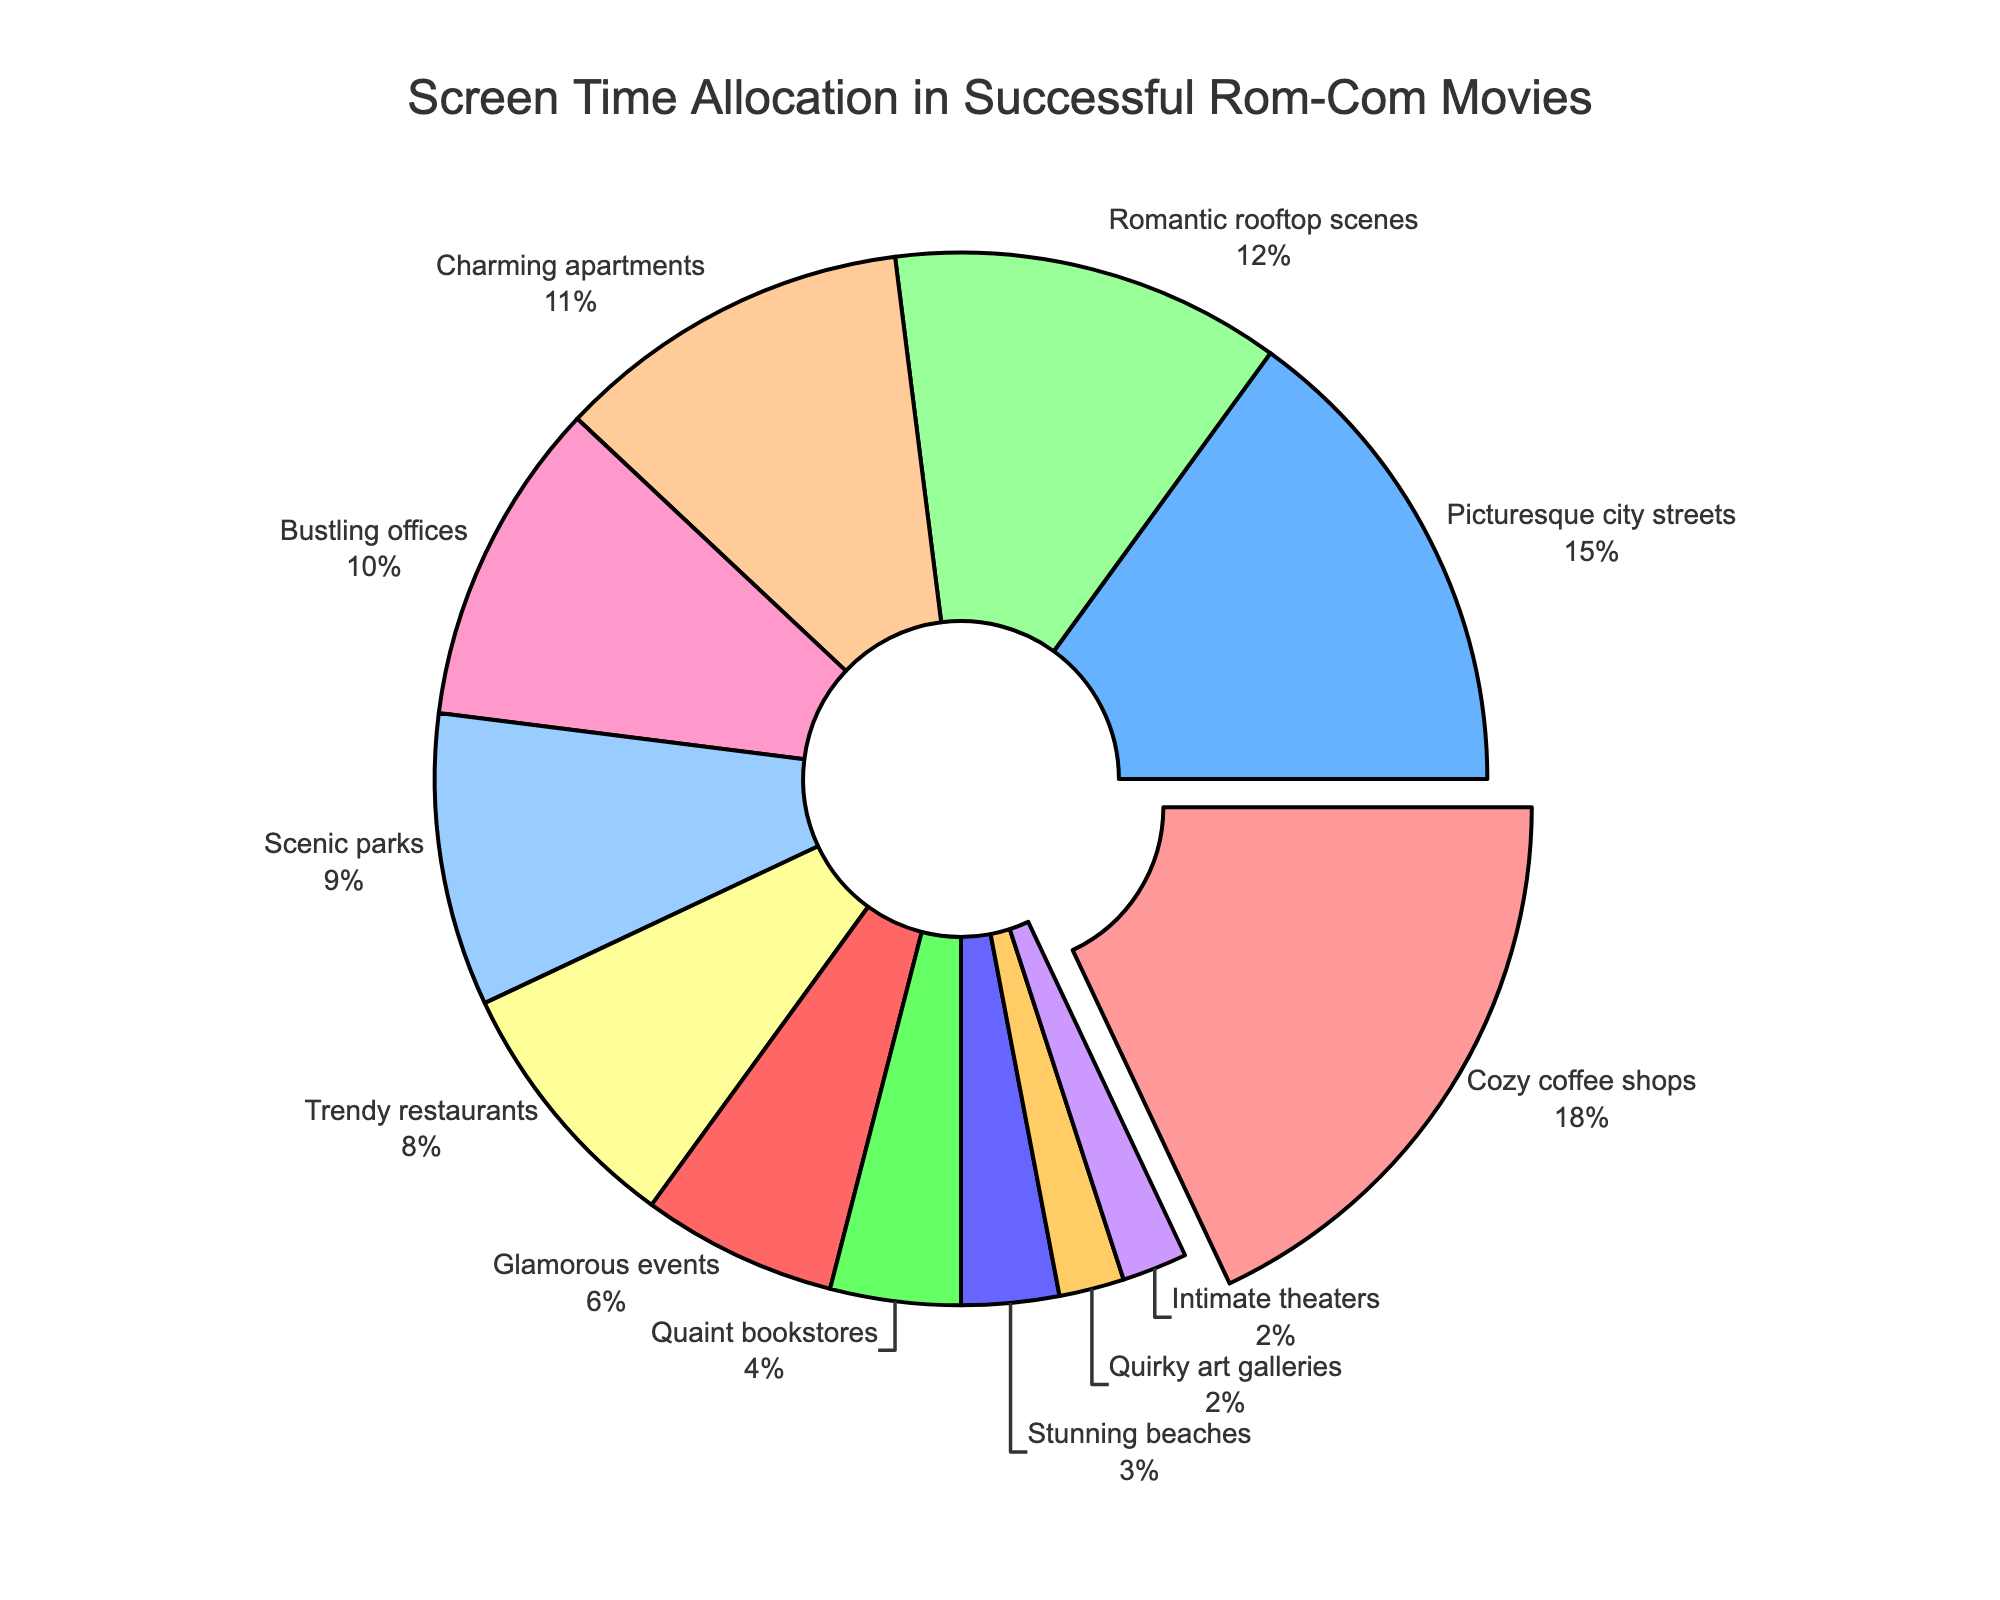What's the location with the highest screen time allocation? The location with the highest screen time allocation is visually highlighted by being pulled out from the rest of the pie chart and its percentage is clearly marked. It is the "Cozy coffee shops" with 18%.
Answer: Cozy coffee shops Which two locations combined have just over 30% of the screen time allocation? We need to add the percentages of different locations to find a combination that just exceeds 30%. "Picturesque city streets" (15%) and "Romantic rooftop scenes" (12%) together give us 27%, but adding "Charming apartments" (11%) results in a sum of 38%, exceeding 30%. Instead, "Cozy coffee shops" (18%) combined with "Picturesque city streets" (15%) gives us 33%, which is just over 30%.
Answer: Cozy coffee shops and Picturesque city streets How do the screen time allocations of "Glamorous events" and "Bustling offices" compare? "Bustling offices" have 10% of the screen time allocation, and "Glamorous events" have 6%. To compare, "Bustling offices" have 4% more screen time allocation than "Glamorous events".
Answer: Bustling offices have more Which location has the smallest screen time allocation? The smallest segment of the pie chart represents this location. It is "Quirky art galleries" and "Intimate theaters", each contributing 2% of the screen time allocation.
Answer: Quirky art galleries and Intimate theaters What is the combined screen time allocation for "Trendy restaurants," "Charming apartments," and "Scenic parks"? Adding the percentages of these locations: "Trendy restaurants" (8%), "Charming apartments" (11%), and "Scenic parks" (9%) gives a total of 8 + 11 + 9 = 28%.
Answer: 28% Is the screen time allocation for "Stunning beaches" greater than that of "Intimate theaters"? "Stunning beaches" have 3% of the screen time allocation, and "Intimate theaters" have 2%. Therefore, the allocation for "Stunning beaches" is greater.
Answer: Yes What percentage of screen time do the top three locations account for? The top three locations are "Cozy coffee shops" (18%), "Picturesque city streets" (15%), and "Romantic rooftop scenes" (12%). Adding these gives 18 + 15 + 12 = 45%.
Answer: 45% Compare the screen time allocation between "Scenic parks" and "Quaint bookstores." "Scenic parks" have 9%, and "Quaint bookstores" have 4%. "Scenic parks" have 5% more screen time than "Quaint bookstores".
Answer: Scenic parks have more Which locations together make up exactly 20% of the screen time? Looking for any combination that sums up to 20. "Bustling offices" (10%) and "Scenic parks" (9%) with "Intimate theaters" (2%) total 10 + 9 + 2 = 21%. However, "Picturesque city streets" (15%) and "Quaint bookstores" (4%) give 19%, not 20. Instead, combining "Charming apartments" (11%) and "Romantic rooftop scenes" (12%) gives us exactly 23%. The exact combination is "Romantic rooftop scenes" (12%) and "Quaint bookstores" (4%) and "Intimate theaters" (2%) - totaling 18% + 4% = 22%, not exact. Hence, there is no exact 20%.
Answer: Not applicable 